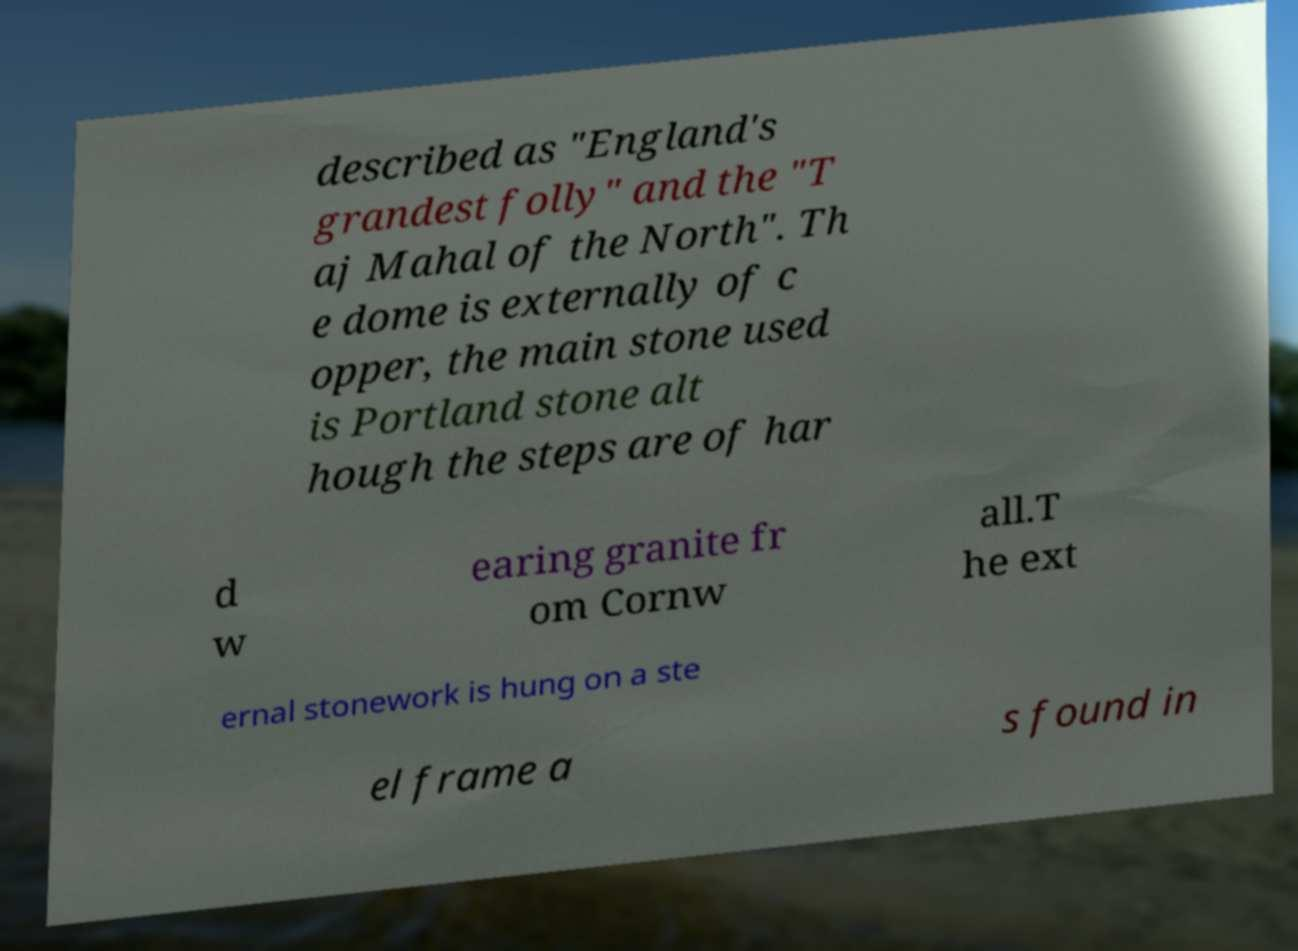Please read and relay the text visible in this image. What does it say? described as "England's grandest folly" and the "T aj Mahal of the North". Th e dome is externally of c opper, the main stone used is Portland stone alt hough the steps are of har d w earing granite fr om Cornw all.T he ext ernal stonework is hung on a ste el frame a s found in 